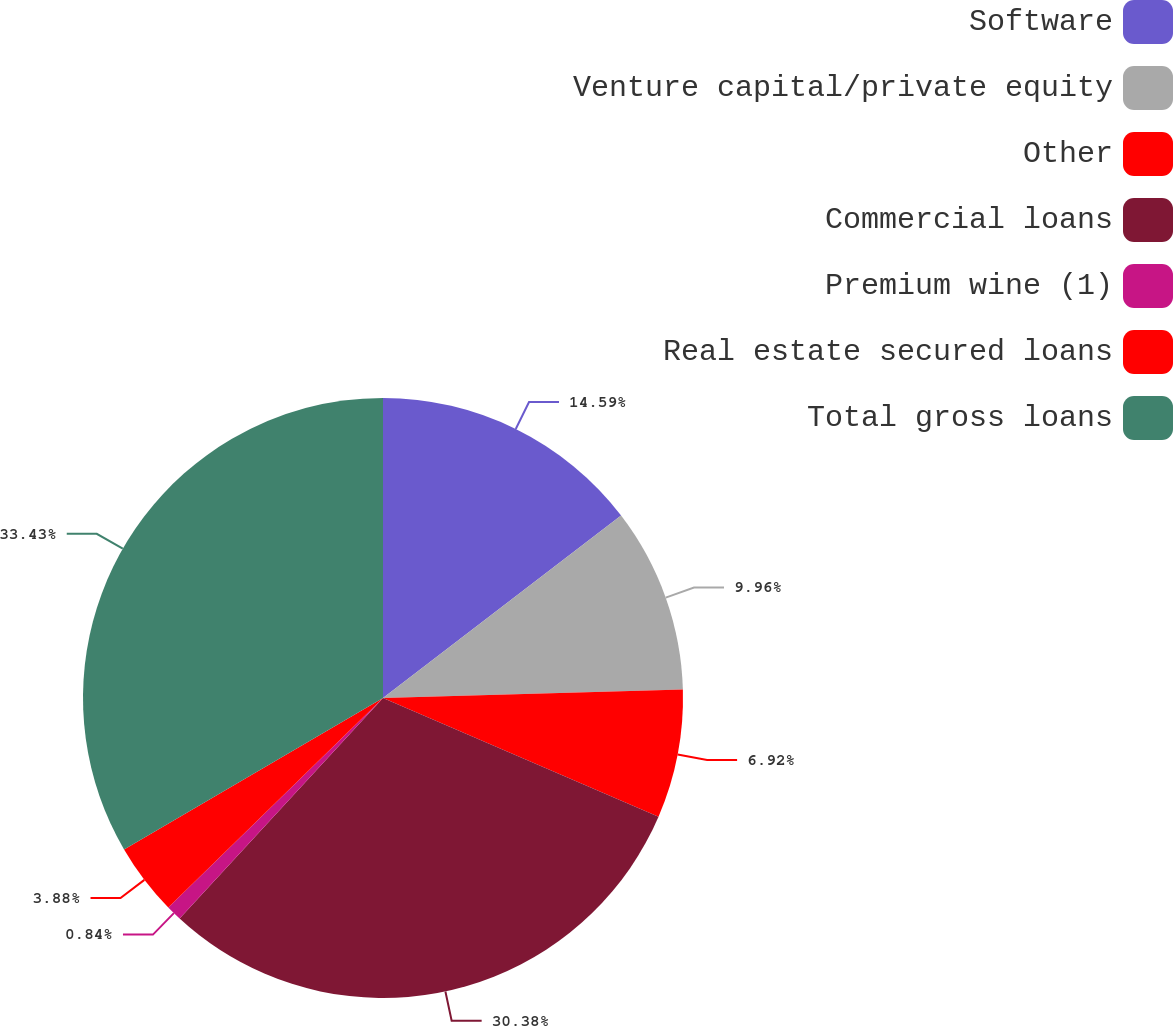Convert chart to OTSL. <chart><loc_0><loc_0><loc_500><loc_500><pie_chart><fcel>Software<fcel>Venture capital/private equity<fcel>Other<fcel>Commercial loans<fcel>Premium wine (1)<fcel>Real estate secured loans<fcel>Total gross loans<nl><fcel>14.59%<fcel>9.96%<fcel>6.92%<fcel>30.38%<fcel>0.84%<fcel>3.88%<fcel>33.42%<nl></chart> 